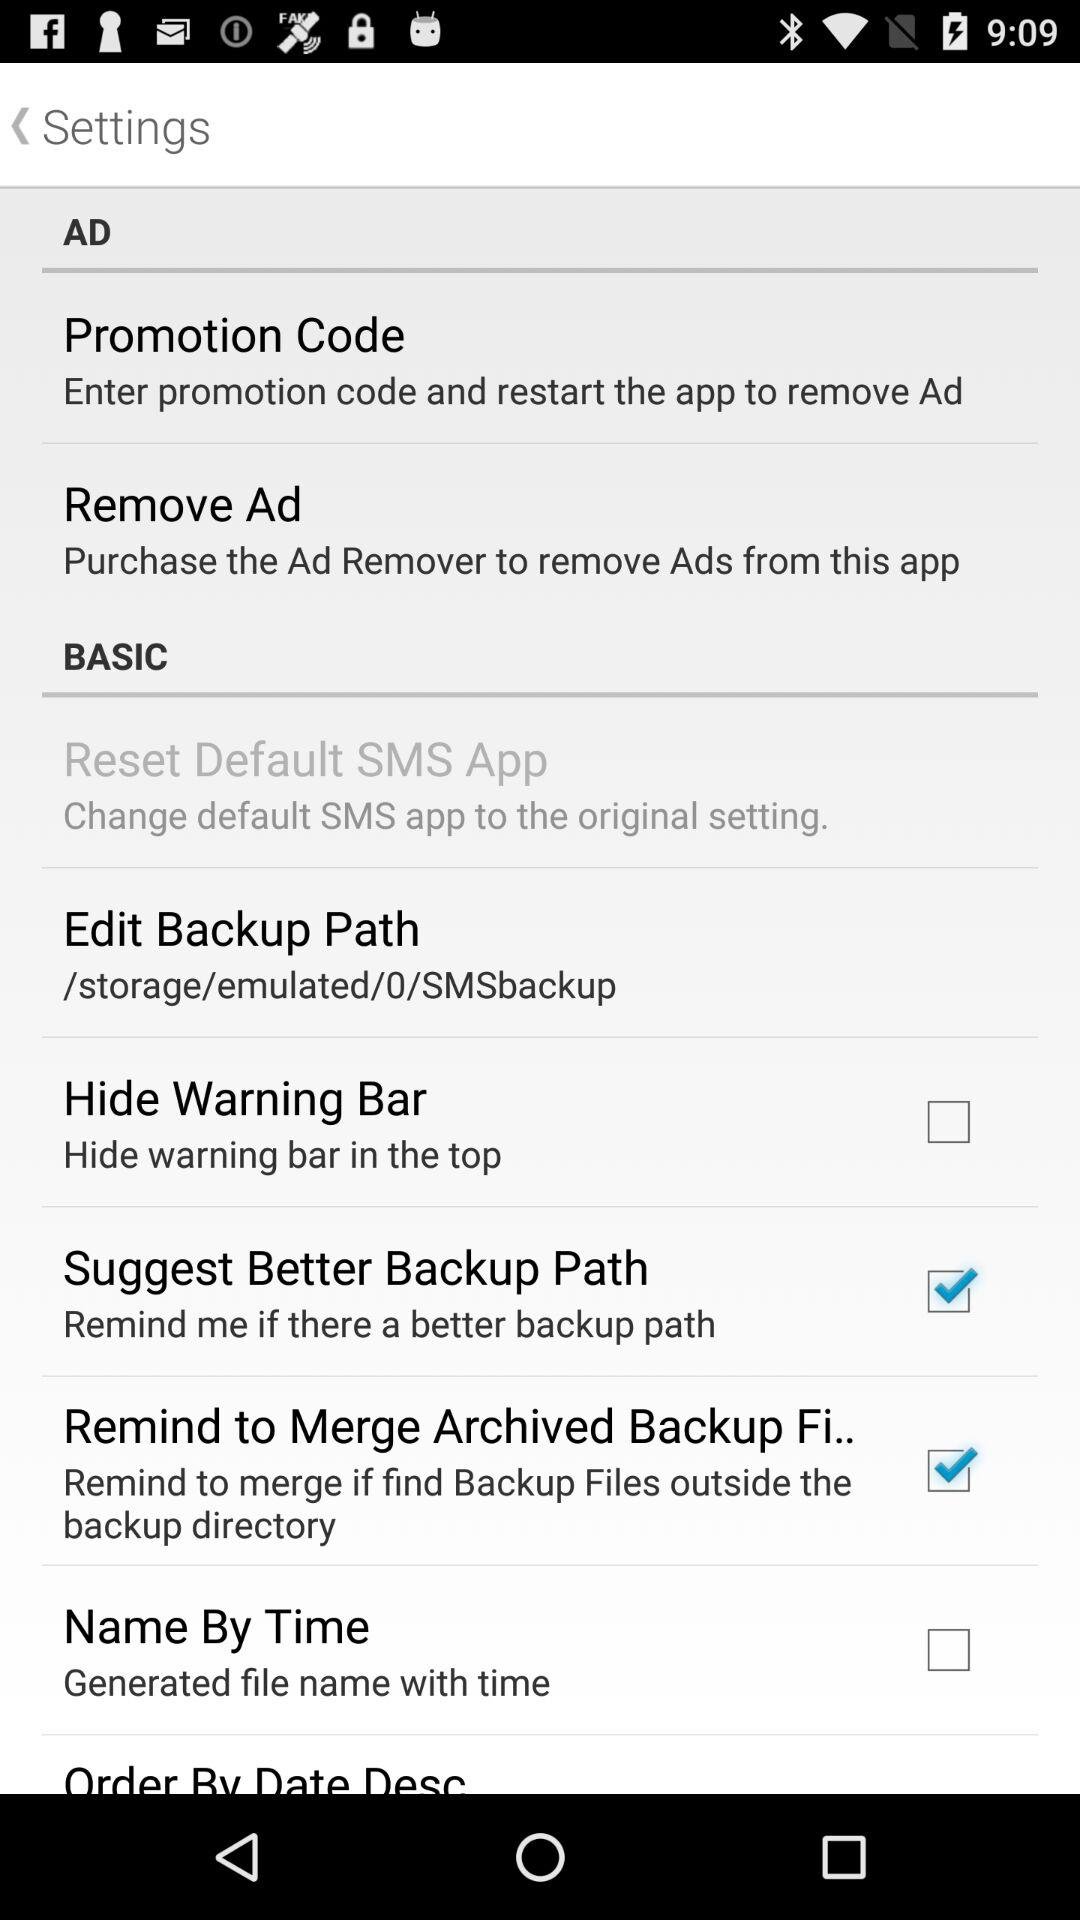What is the status of "Suggest Better Backup Path"? The status of "Suggest Better Backup Path" is "on". 